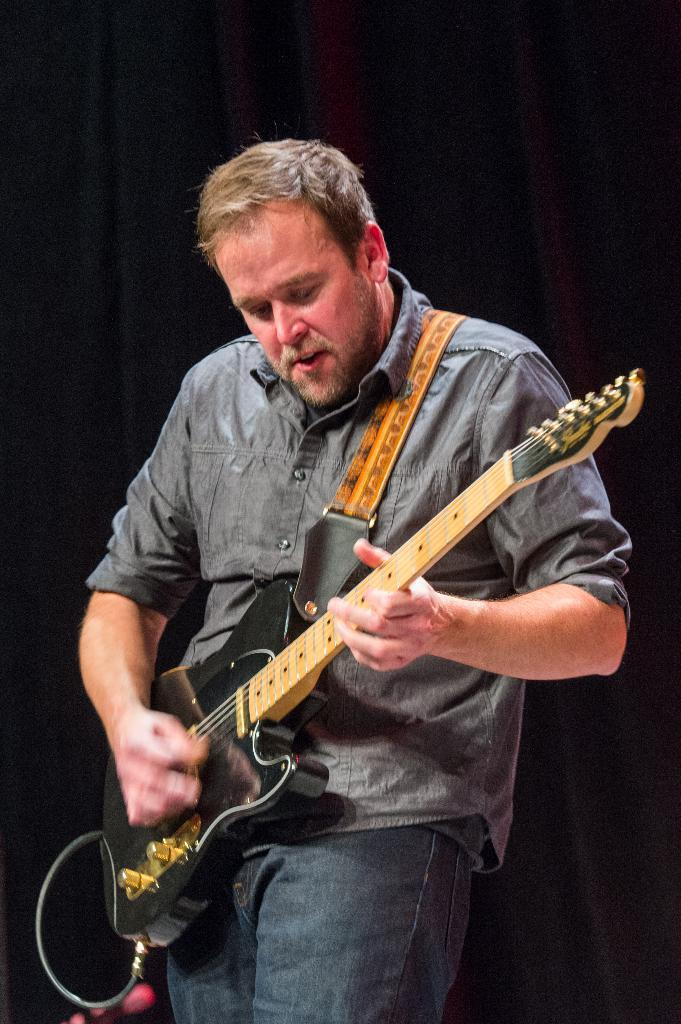What is the main subject of the image? There is a person in the image. What is the person wearing? The person is wearing clothes. What activity is the person engaged in? The person is playing a guitar. How does the boy express regret in the image? There is no boy present in the image, and no expression of regret can be observed. 